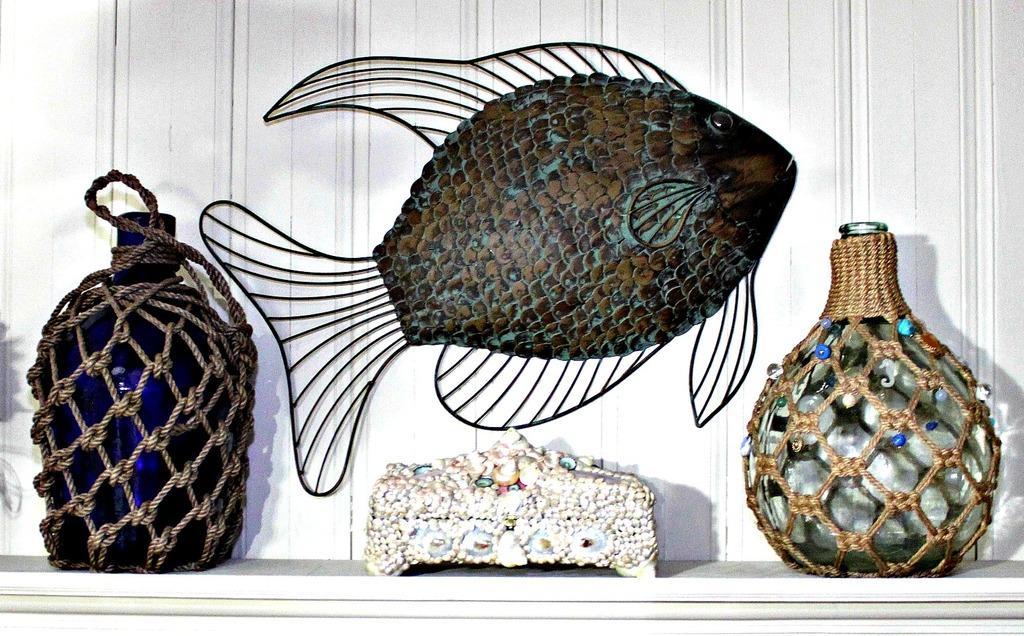Can you describe this image briefly? In the center of this picture we can see the sculpture of a fish and we can see glass bottles in the rope holders and we can see some other object. In the background there is a white color object which seems to be the wall. 